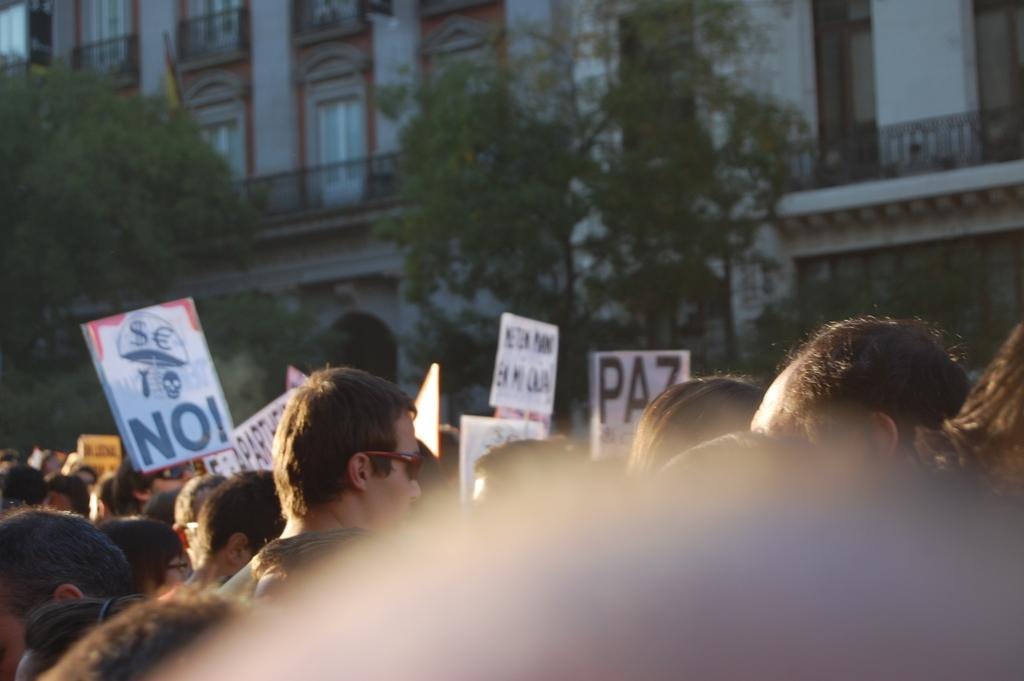What can be seen in the image involving people? There are people standing in the image. What type of objects are present in the image with text or images? There are posters in the image. What type of natural elements can be seen in the image? There are trees in the image. What type of man-made structures are visible in the image? There are buildings in the image. What feature of the buildings can be observed? The buildings have windows. What type of quiver is being used by the writer in the image? There is no writer or quiver present in the image. What is the governor's opinion on the buildings in the image? There is no governor present in the image, so their opinion cannot be determined. 